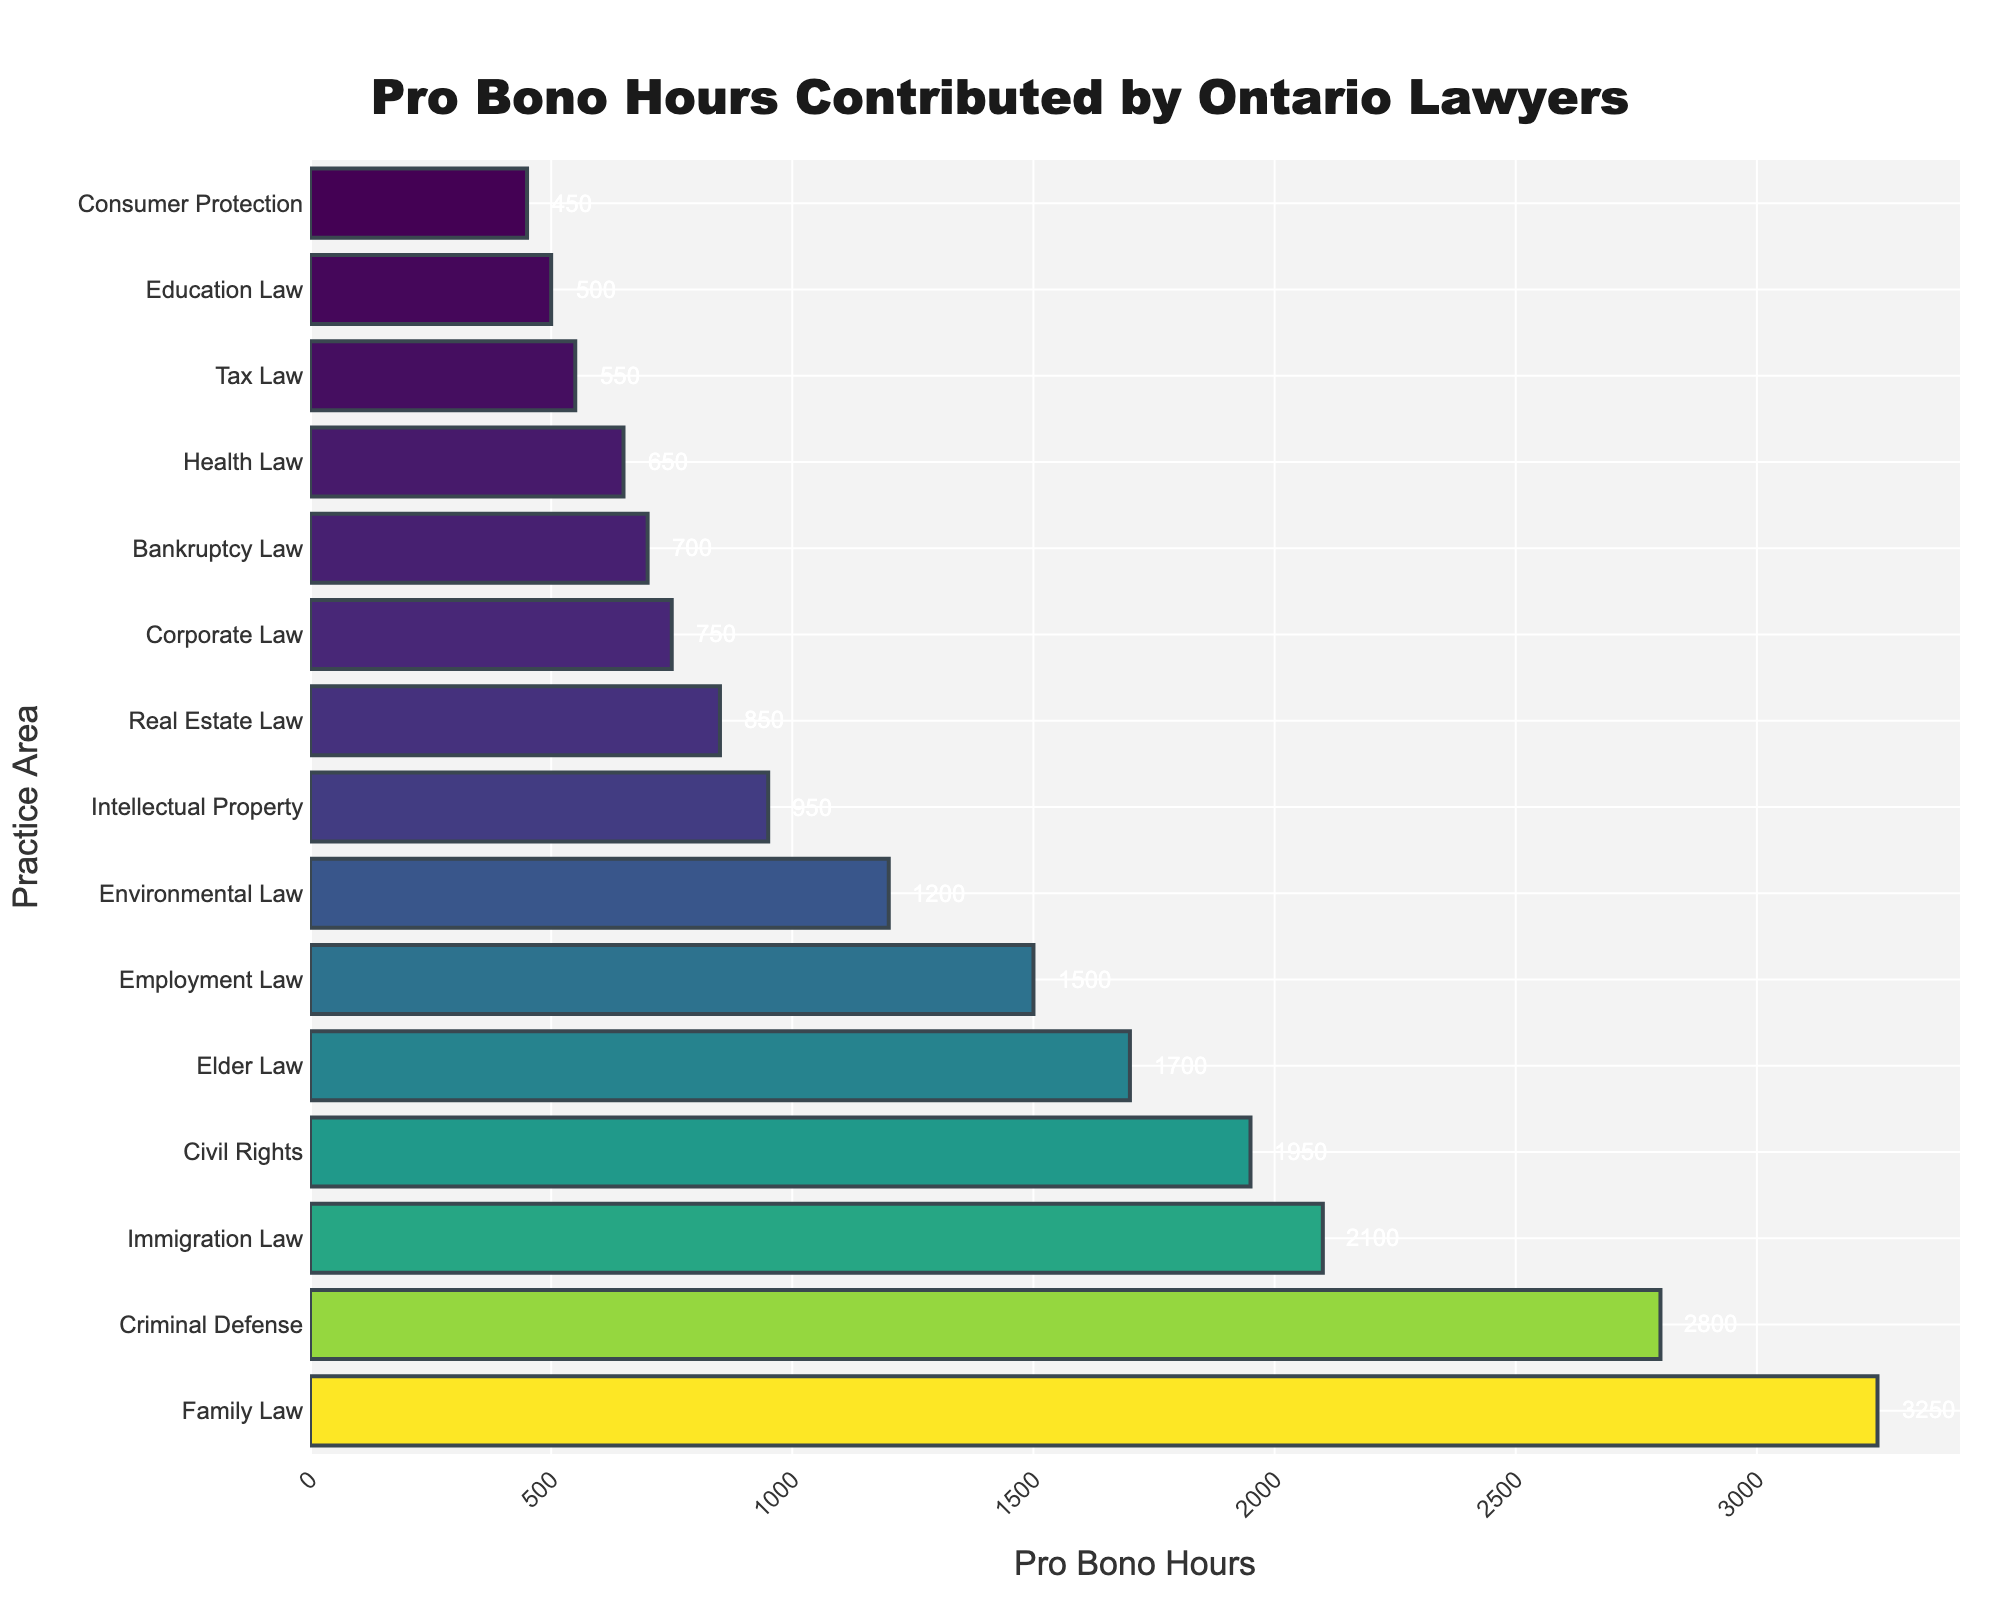What is the total number of pro bono hours contributed by Ontario lawyers in all practice areas? To find the total number of pro bono hours, sum the hours contributed across all practice areas. The sum is 3250 + 2800 + 2100 + 1950 + 1700 + 1500 + 1200 + 950 + 850 + 750 + 700 + 650 + 550 + 500 + 450 = 21500
Answer: 21500 Which practice area received the highest number of pro bono hours? To determine which practice area received the highest number of pro bono hours, find the practice area with the longest bar and its corresponding value. Family Law has the longest bar with 3250 hours.
Answer: Family Law How many more pro bono hours were contributed to Family Law compared to Bankruptcy Law? Calculate the difference in pro bono hours between Family Law and Bankruptcy Law: 3250 (Family Law) - 700 (Bankruptcy Law) = 2550.
Answer: 2550 Which practice areas received fewer than 1000 pro bono hours? Identify the practice areas where the bars are shorter or equal to the bar representing 950 hours. These are Intellectual Property, Real Estate Law, Corporate Law, Bankruptcy Law, Health Law, Tax Law, Education Law, and Consumer Protection.
Answer: Intellectual Property, Real Estate Law, Corporate Law, Bankruptcy Law, Health Law, Tax Law, Education Law, Consumer Protection What is the average number of pro bono hours contributed per practice area? To find the average pro bono hours, divide the total pro bono hours by the number of practice areas. The total is 21500 hours, and there are 15 practice areas. So, 21500 / 15 = 1433.33 hours.
Answer: 1433.33 How does the number of pro bono hours in Employment Law compare to Elder Law? Compare the pro bono hours directly: Employment Law has 1500 hours, while Elder Law has 1700 hours. Employment Law has fewer pro bono hours than Elder Law by 1700 - 1500 = 200 hours.
Answer: Employment Law has 200 fewer hours What is the combined pro bono hours for Civil Rights and Immigration Law? Add the pro bono hours for Civil Rights and Immigration Law: 1950 (Civil Rights) + 2100 (Immigration Law) = 4050.
Answer: 4050 What percentage of the total pro bono hours is contributed by Health Law? Calculate the percentage by dividing Health Law’s hours by the total pro bono hours and multiplying by 100. Health Law has 650 hours; total hours are 21500. So, (650 / 21500) * 100 ≈ 3.02%.
Answer: 3.02% Which practice area contributed the lowest number of pro bono hours? Identify the practice area with the shortest bar and its corresponding value. Consumer Protection has the shortest bar with 450 pro bono hours.
Answer: Consumer Protection 